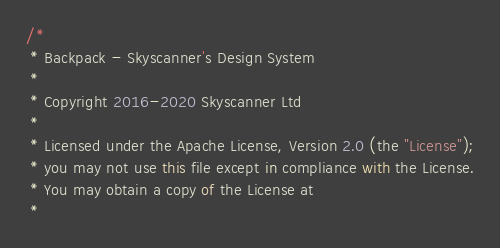Convert code to text. <code><loc_0><loc_0><loc_500><loc_500><_JavaScript_>/*
 * Backpack - Skyscanner's Design System
 *
 * Copyright 2016-2020 Skyscanner Ltd
 *
 * Licensed under the Apache License, Version 2.0 (the "License");
 * you may not use this file except in compliance with the License.
 * You may obtain a copy of the License at
 *</code> 